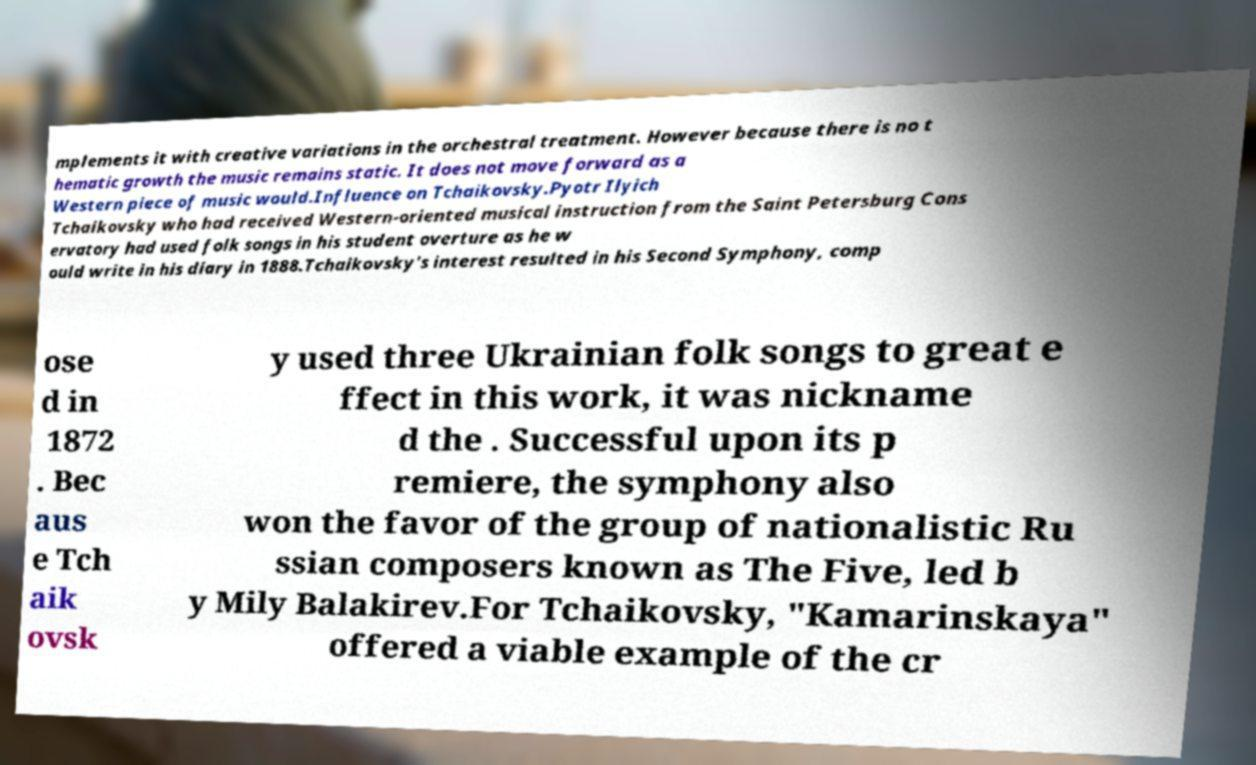There's text embedded in this image that I need extracted. Can you transcribe it verbatim? mplements it with creative variations in the orchestral treatment. However because there is no t hematic growth the music remains static. It does not move forward as a Western piece of music would.Influence on Tchaikovsky.Pyotr Ilyich Tchaikovsky who had received Western-oriented musical instruction from the Saint Petersburg Cons ervatory had used folk songs in his student overture as he w ould write in his diary in 1888.Tchaikovsky's interest resulted in his Second Symphony, comp ose d in 1872 . Bec aus e Tch aik ovsk y used three Ukrainian folk songs to great e ffect in this work, it was nickname d the . Successful upon its p remiere, the symphony also won the favor of the group of nationalistic Ru ssian composers known as The Five, led b y Mily Balakirev.For Tchaikovsky, "Kamarinskaya" offered a viable example of the cr 